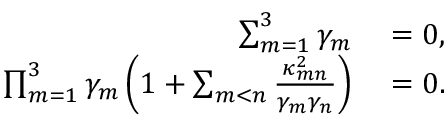Convert formula to latex. <formula><loc_0><loc_0><loc_500><loc_500>\begin{array} { r l } { \sum _ { m = 1 } ^ { 3 } \gamma _ { m } } & = 0 , } \\ { \prod _ { m = 1 } ^ { 3 } \gamma _ { m } \left ( 1 + \sum _ { m < n } \frac { \kappa _ { m n } ^ { 2 } } { \gamma _ { m } \gamma _ { n } } \right ) } & = 0 . } \end{array}</formula> 